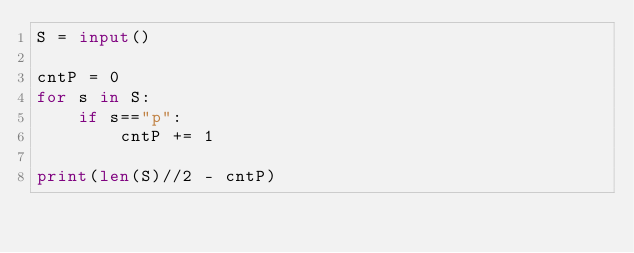Convert code to text. <code><loc_0><loc_0><loc_500><loc_500><_Python_>S = input()

cntP = 0
for s in S:
    if s=="p":
        cntP += 1

print(len(S)//2 - cntP)
</code> 